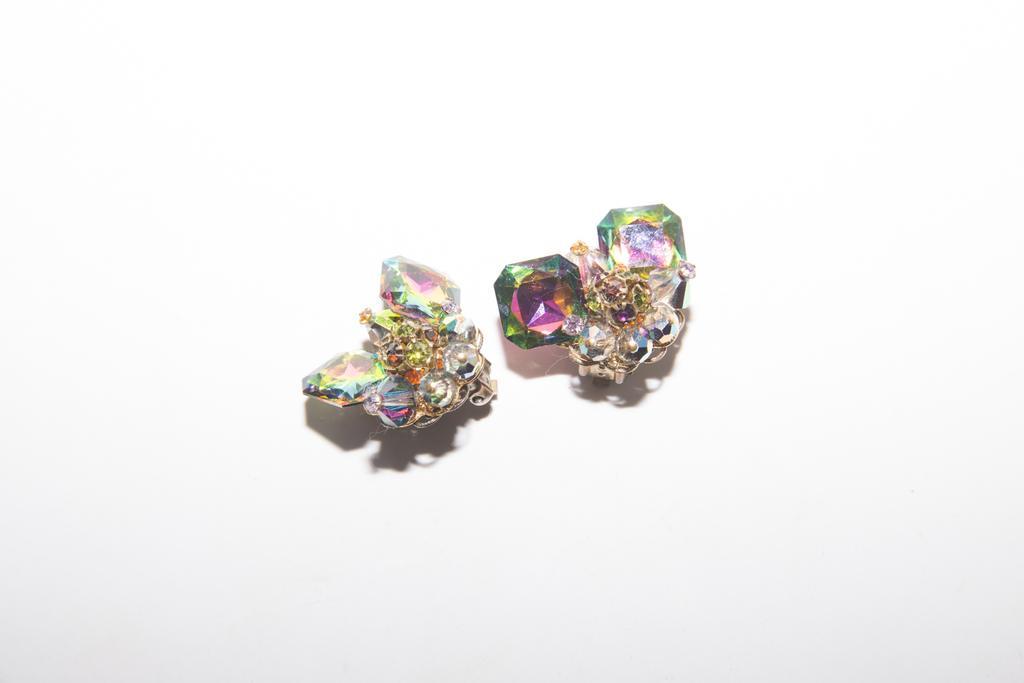Please provide a concise description of this image. In this picture I can see 2 jewelries on the white color surface. 